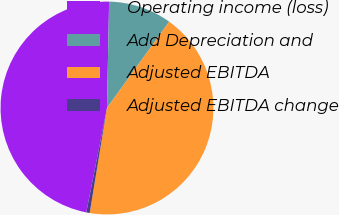Convert chart. <chart><loc_0><loc_0><loc_500><loc_500><pie_chart><fcel>Operating income (loss)<fcel>Add Depreciation and<fcel>Adjusted EBITDA<fcel>Adjusted EBITDA change<nl><fcel>47.2%<fcel>9.62%<fcel>42.65%<fcel>0.52%<nl></chart> 